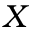<formula> <loc_0><loc_0><loc_500><loc_500>X</formula> 